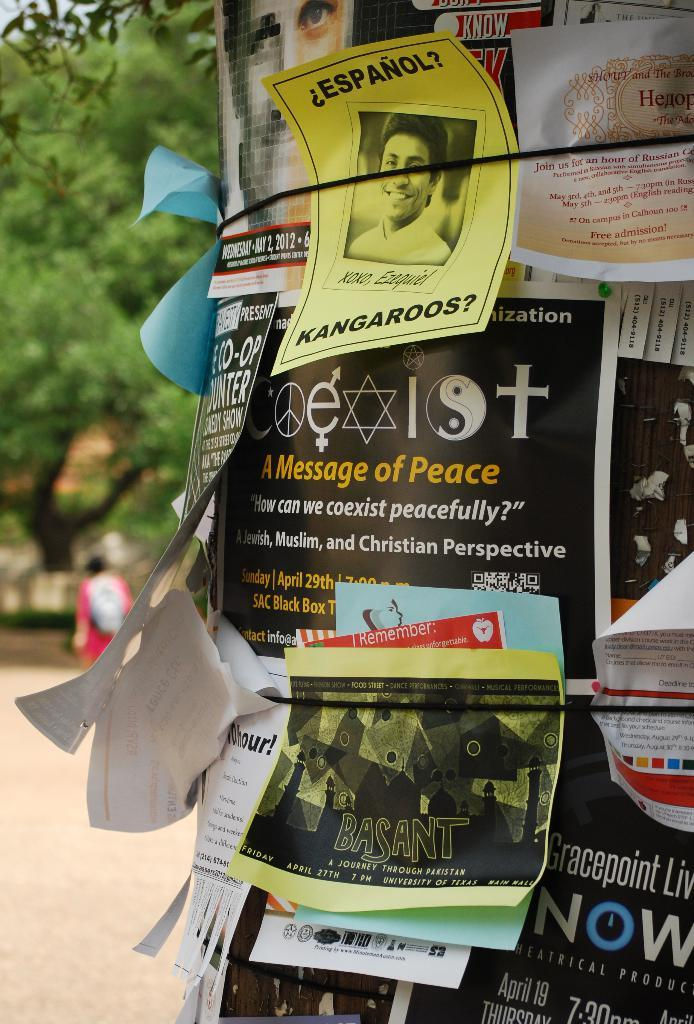<image>
Write a terse but informative summary of the picture. A bunch of flyers tied to a tree with one flyer announcing "A Message of Peace" 